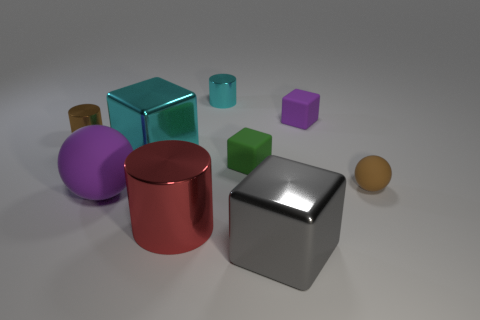What can you infer about the setting of these objects? Based on the image, the objects are set against a neutral background with soft shadowing, which suggests a controlled, studio-like environment likely designed to emphasize the forms and colors of the objects without distraction. 